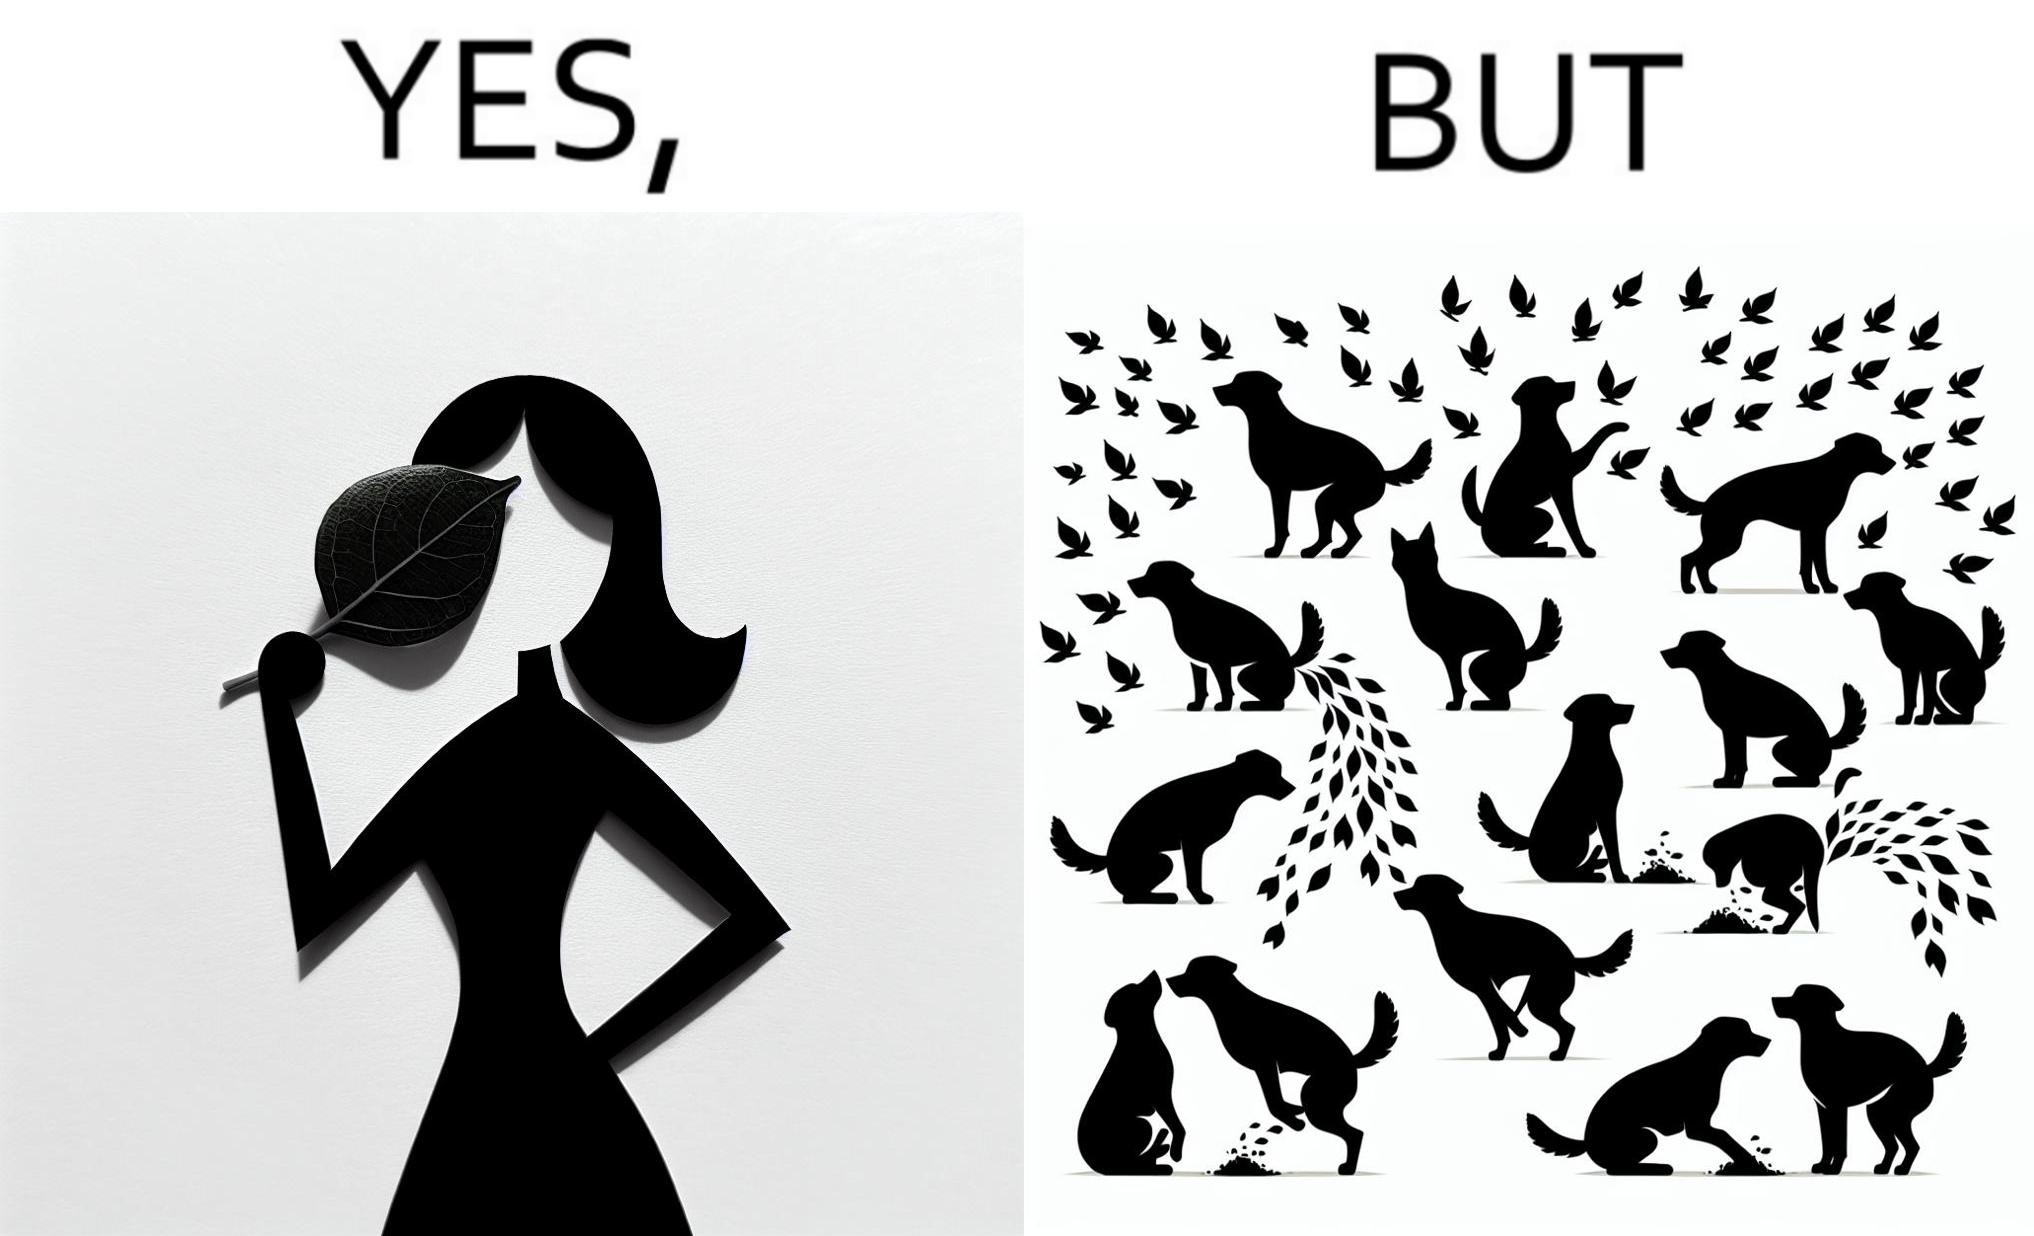Compare the left and right sides of this image. In the left part of the image: It is a woman holding a leaf over half of her face for a good photo In the right part of the image: It is a few dogs defecating and urinating over leaves 